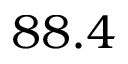<formula> <loc_0><loc_0><loc_500><loc_500>8 8 . 4</formula> 